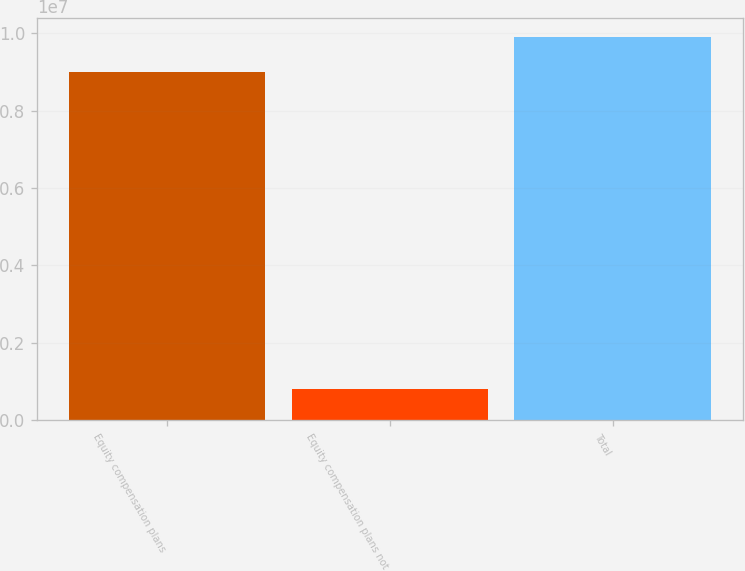Convert chart. <chart><loc_0><loc_0><loc_500><loc_500><bar_chart><fcel>Equity compensation plans<fcel>Equity compensation plans not<fcel>Total<nl><fcel>8.99594e+06<fcel>811190<fcel>9.89553e+06<nl></chart> 